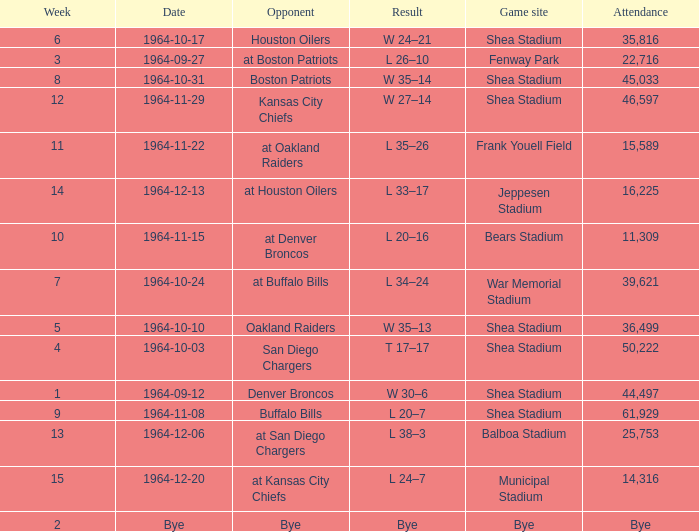Where did the Jet's play with an attendance of 11,309? Bears Stadium. 